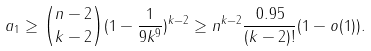<formula> <loc_0><loc_0><loc_500><loc_500>a _ { 1 } \geq { { n - 2 } \choose { k - 2 } } ( 1 - \frac { 1 } { 9 k ^ { 9 } } ) ^ { k - 2 } \geq n ^ { k - 2 } \frac { 0 . 9 5 } { ( k - 2 ) ! } ( 1 - o ( 1 ) ) .</formula> 